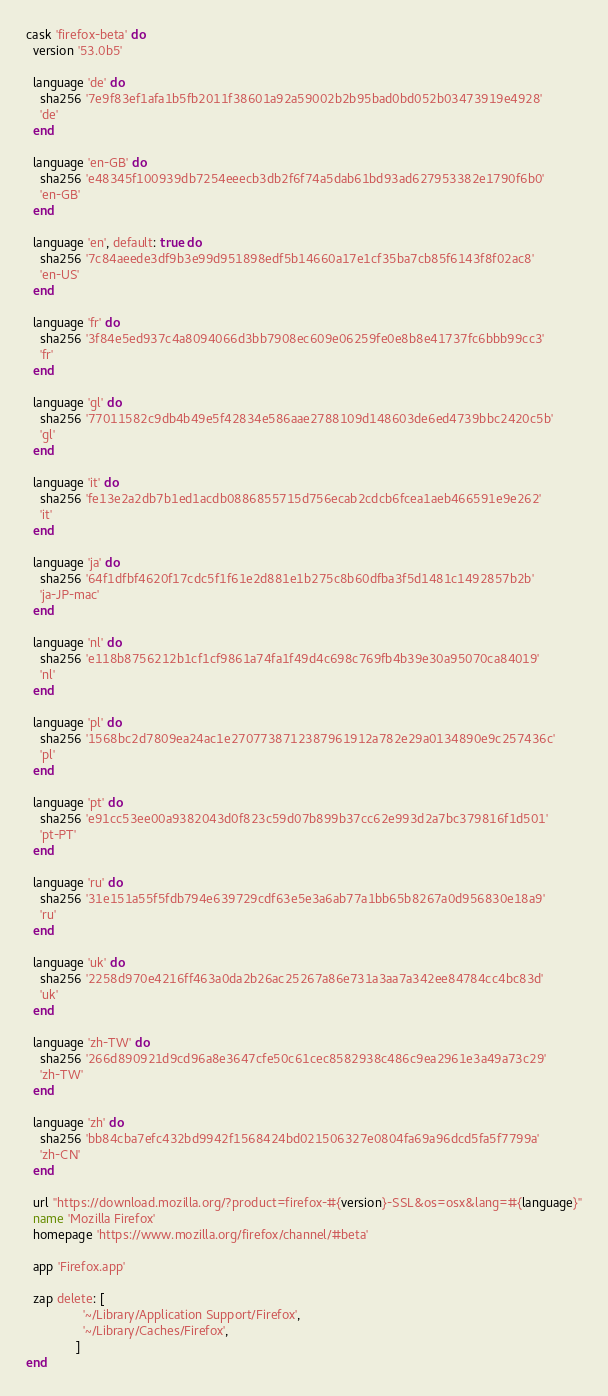<code> <loc_0><loc_0><loc_500><loc_500><_Ruby_>cask 'firefox-beta' do
  version '53.0b5'

  language 'de' do
    sha256 '7e9f83ef1afa1b5fb2011f38601a92a59002b2b95bad0bd052b03473919e4928'
    'de'
  end

  language 'en-GB' do
    sha256 'e48345f100939db7254eeecb3db2f6f74a5dab61bd93ad627953382e1790f6b0'
    'en-GB'
  end

  language 'en', default: true do
    sha256 '7c84aeede3df9b3e99d951898edf5b14660a17e1cf35ba7cb85f6143f8f02ac8'
    'en-US'
  end

  language 'fr' do
    sha256 '3f84e5ed937c4a8094066d3bb7908ec609e06259fe0e8b8e41737fc6bbb99cc3'
    'fr'
  end

  language 'gl' do
    sha256 '77011582c9db4b49e5f42834e586aae2788109d148603de6ed4739bbc2420c5b'
    'gl'
  end

  language 'it' do
    sha256 'fe13e2a2db7b1ed1acdb0886855715d756ecab2cdcb6fcea1aeb466591e9e262'
    'it'
  end

  language 'ja' do
    sha256 '64f1dfbf4620f17cdc5f1f61e2d881e1b275c8b60dfba3f5d1481c1492857b2b'
    'ja-JP-mac'
  end

  language 'nl' do
    sha256 'e118b8756212b1cf1cf9861a74fa1f49d4c698c769fb4b39e30a95070ca84019'
    'nl'
  end

  language 'pl' do
    sha256 '1568bc2d7809ea24ac1e2707738712387961912a782e29a0134890e9c257436c'
    'pl'
  end

  language 'pt' do
    sha256 'e91cc53ee00a9382043d0f823c59d07b899b37cc62e993d2a7bc379816f1d501'
    'pt-PT'
  end

  language 'ru' do
    sha256 '31e151a55f5fdb794e639729cdf63e5e3a6ab77a1bb65b8267a0d956830e18a9'
    'ru'
  end

  language 'uk' do
    sha256 '2258d970e4216ff463a0da2b26ac25267a86e731a3aa7a342ee84784cc4bc83d'
    'uk'
  end

  language 'zh-TW' do
    sha256 '266d890921d9cd96a8e3647cfe50c61cec8582938c486c9ea2961e3a49a73c29'
    'zh-TW'
  end

  language 'zh' do
    sha256 'bb84cba7efc432bd9942f1568424bd021506327e0804fa69a96dcd5fa5f7799a'
    'zh-CN'
  end

  url "https://download.mozilla.org/?product=firefox-#{version}-SSL&os=osx&lang=#{language}"
  name 'Mozilla Firefox'
  homepage 'https://www.mozilla.org/firefox/channel/#beta'

  app 'Firefox.app'

  zap delete: [
                '~/Library/Application Support/Firefox',
                '~/Library/Caches/Firefox',
              ]
end
</code> 